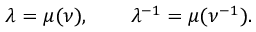Convert formula to latex. <formula><loc_0><loc_0><loc_500><loc_500>\lambda = \mu ( \nu ) , \quad \lambda ^ { - 1 } = \mu ( \nu ^ { - 1 } ) .</formula> 